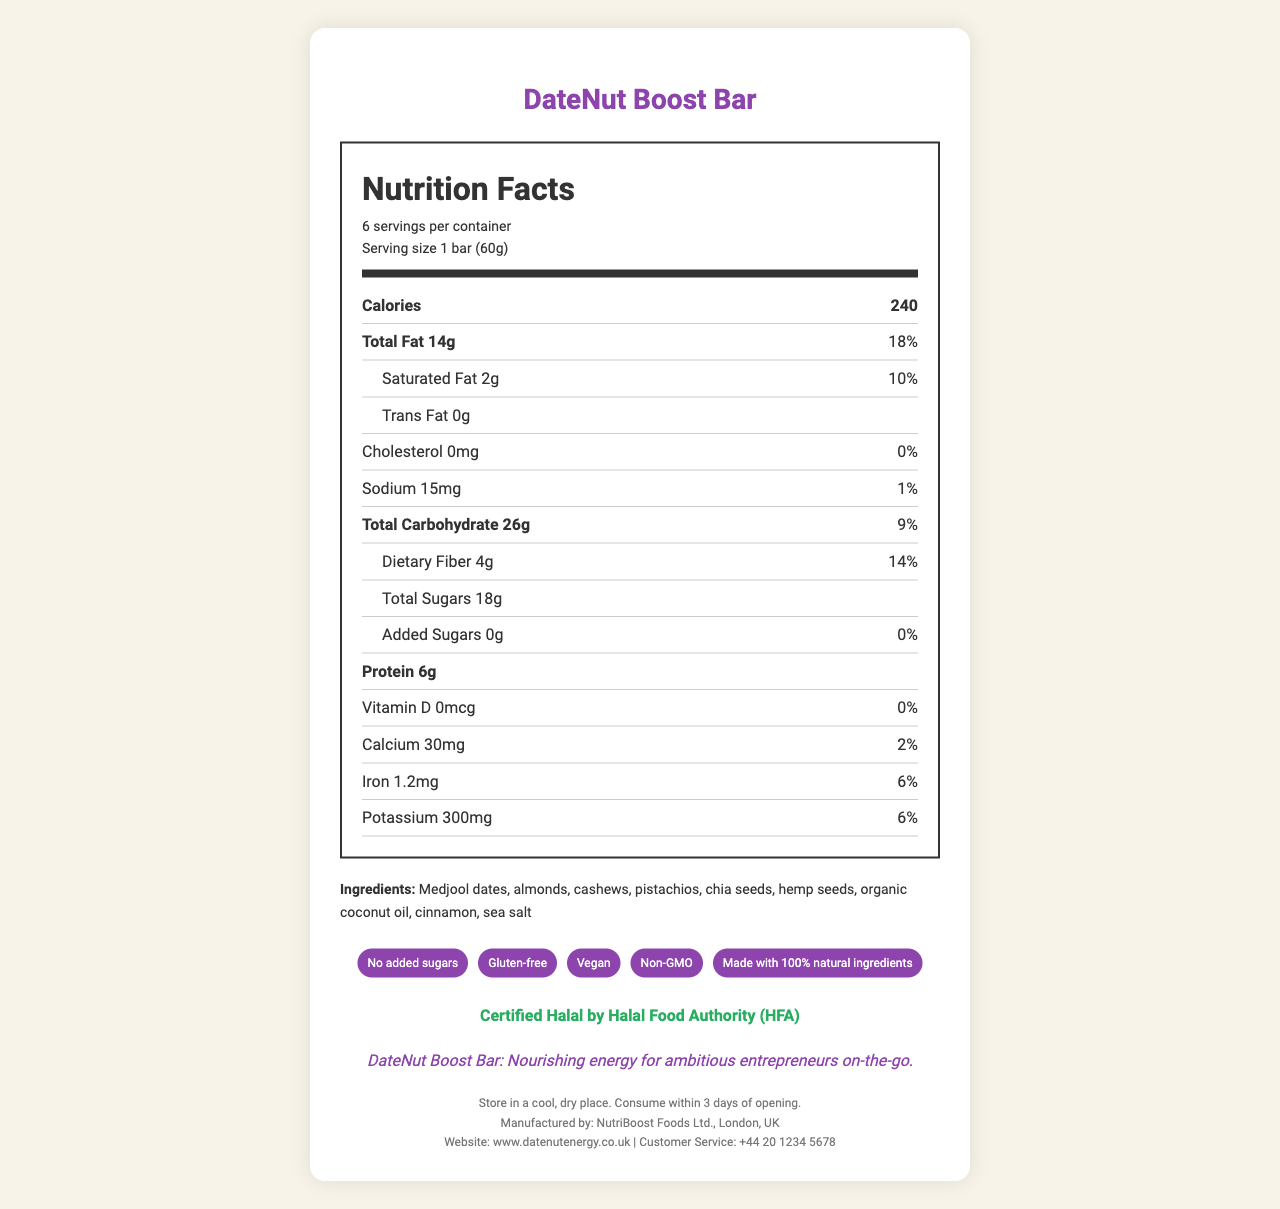what is the serving size? The serving size is mentioned near the top of the nutrition label.
Answer: 1 bar (60g) how many calories are in one serving? The calories are listed prominently near the top of the nutrition facts.
Answer: 240 name two main ingredients of the DateNut Boost Bar. The ingredients are listed at the bottom of the nutrition label, starting with Medjool dates and almonds.
Answer: Medjool dates, almonds does the DateNut Boost Bar contain any added sugars? The added sugars section shows "0g" and "0%" daily value, indicating no added sugars.
Answer: No what is the daily value percentage for saturated fat? The daily value for saturated fat is listed directly beside "Saturated Fat 2g."
Answer: 10% what is the daily value percentage for iron? The daily value for iron is found in the nutrition items section.
Answer: 6% how many grams of dietary fiber are in one serving? The dietary fiber content is specified under "Total Carbohydrate."
Answer: 4g how many servings are there per container? A. 4 B. 6 C. 8 D. 10 The document states that there are 6 servings per container.
Answer: B what is the amount of potassium in one bar? A. 100mg B. 200mg C. 300mg D. 400mg The nutrition label lists potassium as 300mg.
Answer: C is the DateNut Boost Bar gluten-free? One of the additional claims states that it is gluten-free.
Answer: Yes is the DateNut Boost Bar certified Halal? The Halal certification is mentioned clearly in the document ("Certified Halal by Halal Food Authority (HFA)").
Answer: Yes summarize the main purpose of this document. The document provides comprehensive information about the product's contents and health claims, catering to health-conscious consumers and those with dietary restrictions.
Answer: This document details the nutritional information of the DateNut Boost Bar, including calories, macronutrients, vitamins, and minerals. It emphasizes key features like being gluten-free, vegan, and having no added sugars. It also provides information on the manufacturer, storage instructions, and certifications like Halal. what is the manufacturing company of the DateNut Boost Bar? The manufacturer is listed at the bottom of the document.
Answer: NutriBoost Foods Ltd. what is the website for more information on the DateNut Boost Bar? The website is provided in the footer of the document.
Answer: www.datenutenergy.co.uk does the DateNut Boost Bar contain any cholesterol? The nutrition label shows "0mg" for cholesterol, indicating it doesn't contain any.
Answer: No how much protein does one DateNut Boost Bar contain? The amount of protein is listed in the nutrition facts section.
Answer: 6g what is the recommended storage condition for the DateNut Boost Bar after opening? Storage instructions are given in the footer section.
Answer: Store in a cool, dry place. Consume within 3 days of opening. does this bar contain soy? The allergen info mentions that it is produced in a facility that also processes soy, but does not mention if soy is a direct ingredient.
Answer: Not enough information 